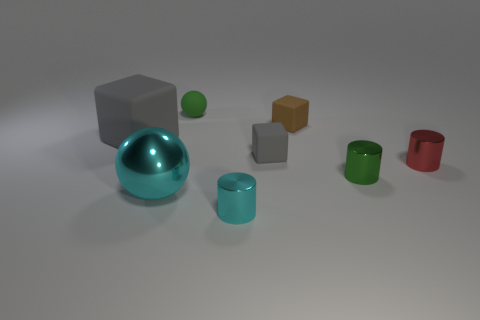What number of large objects are there? 2 